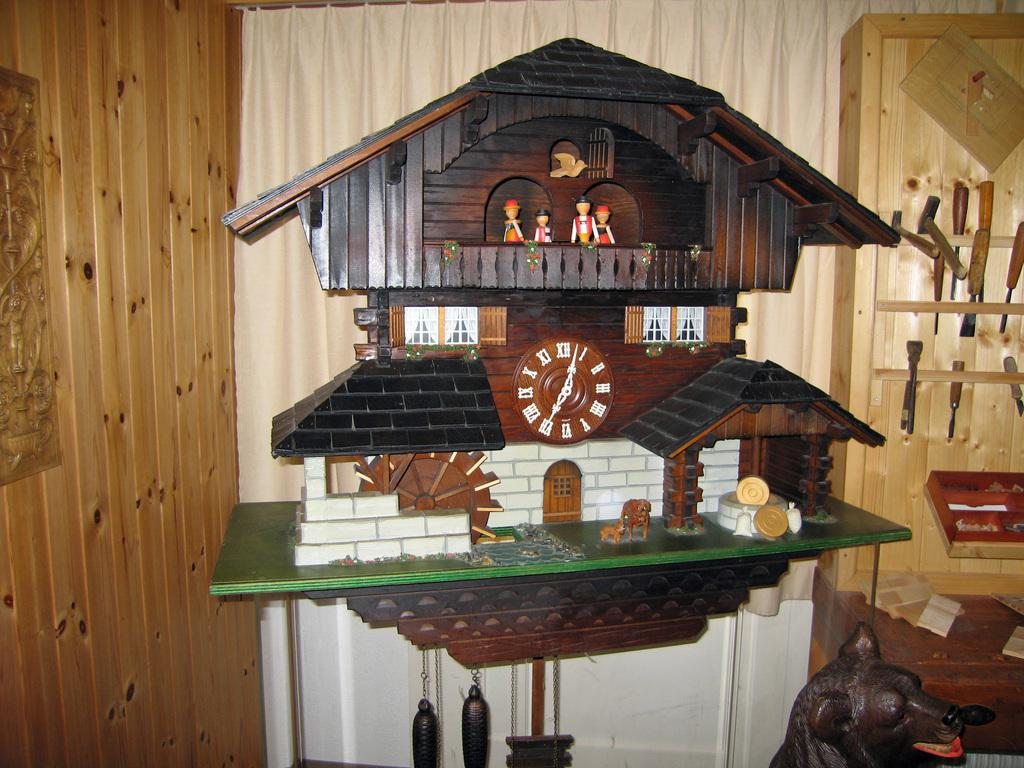<image>
Share a concise interpretation of the image provided. Large brown clock with the hands on the roman numberal 1 and 7. 